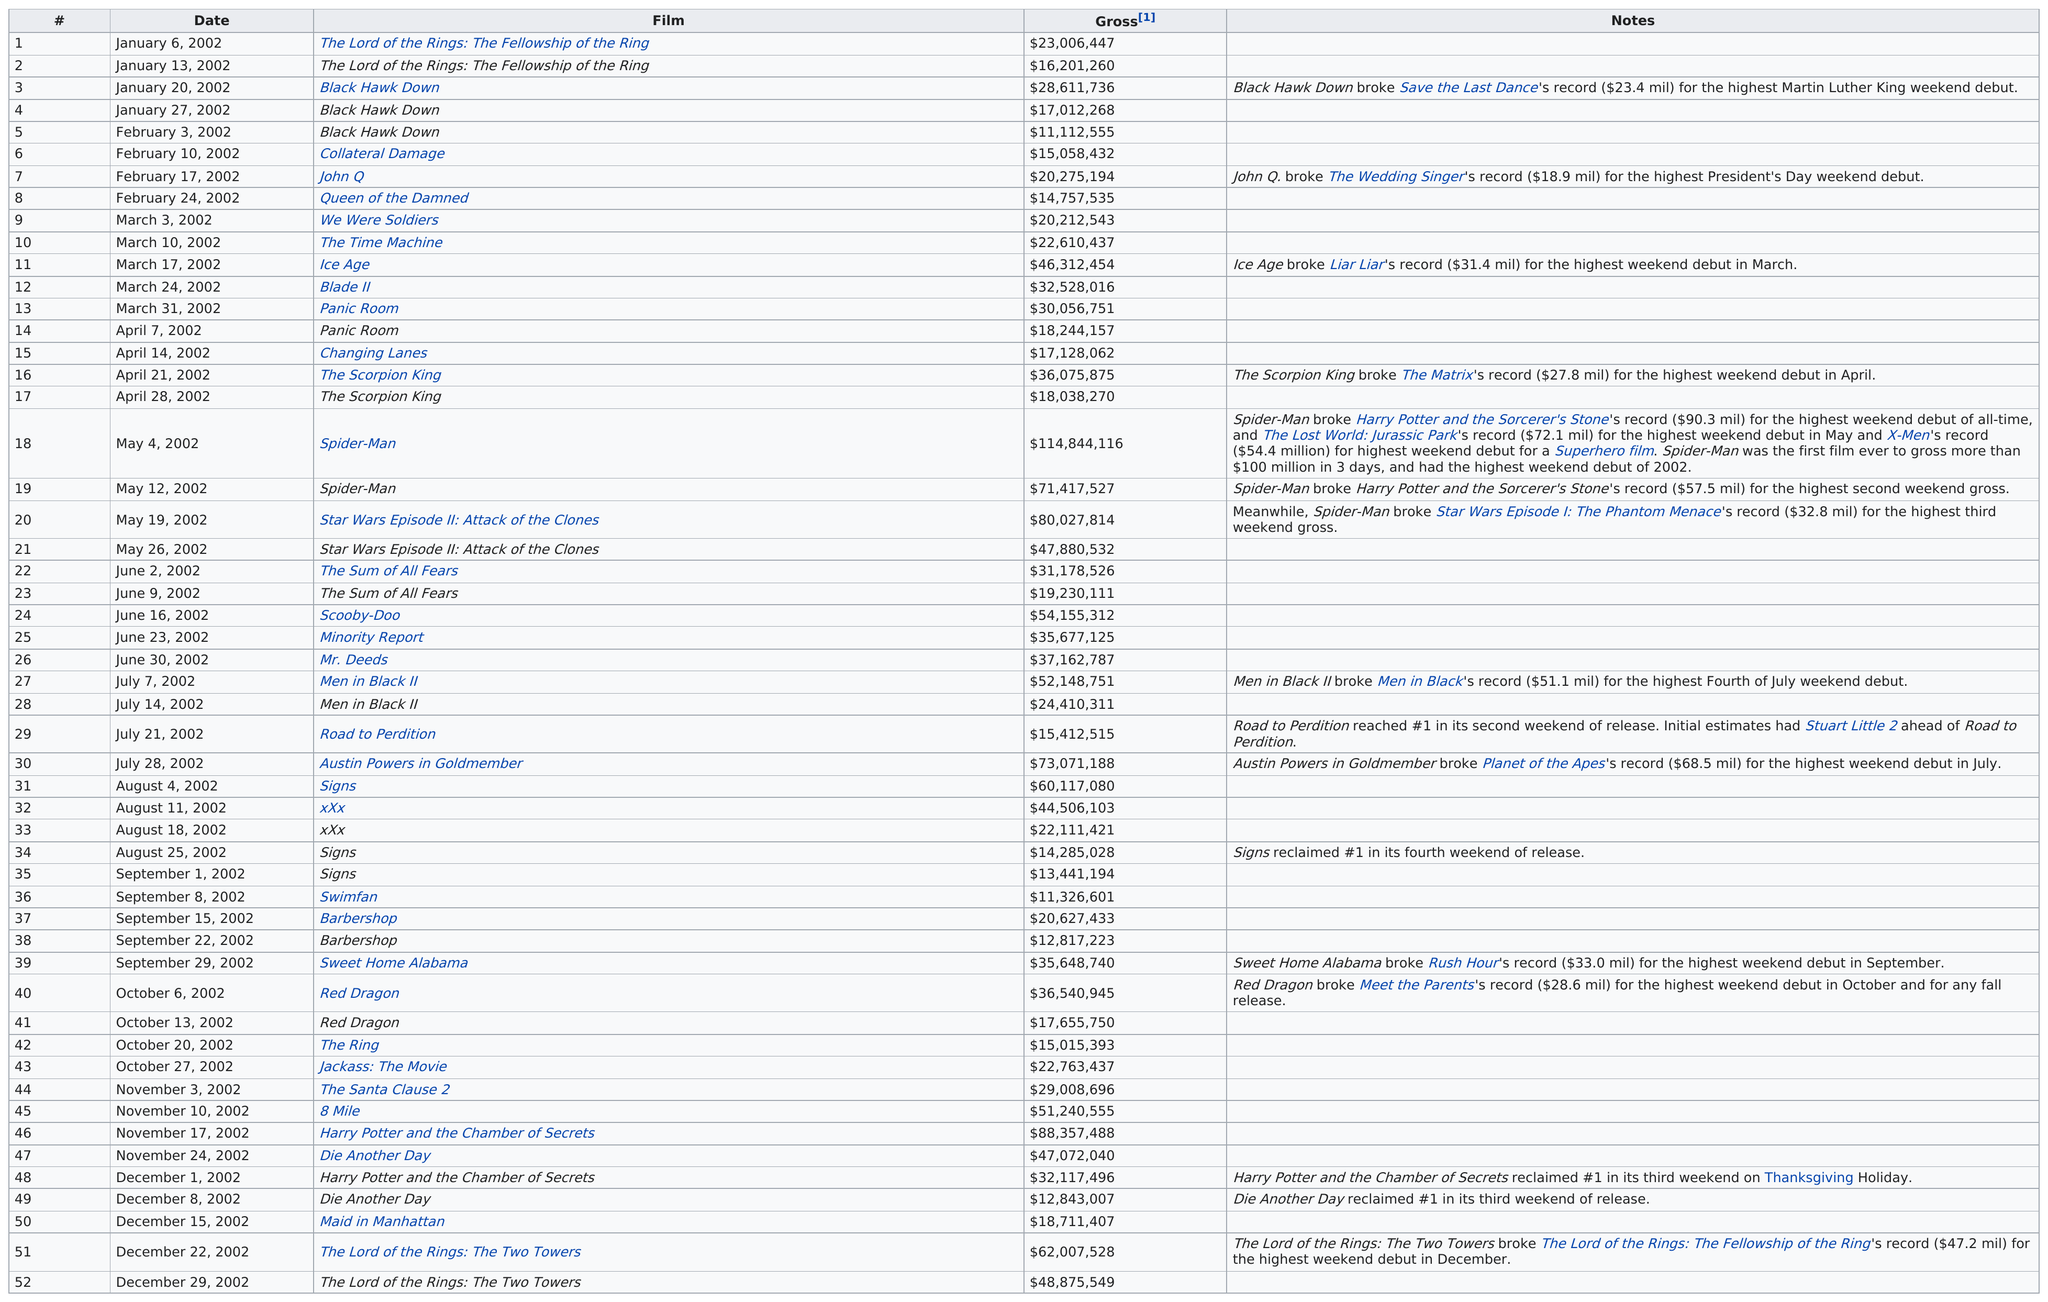Draw attention to some important aspects in this diagram. Queen of the Damned," which was released before March 3, 2002, is the lowest grossing film listed on the chart. The first film released in 2002 was 'The Lord of the Rings: The Fellowship of the Ring' The movie that released in 2002 that grossed the most money is Spider-Man. Out of the total number of films that grossed more than $80,000,000, three of them did so. The film that aired prior to 'Collateral Damage' was 'Black Hawk Down.' 